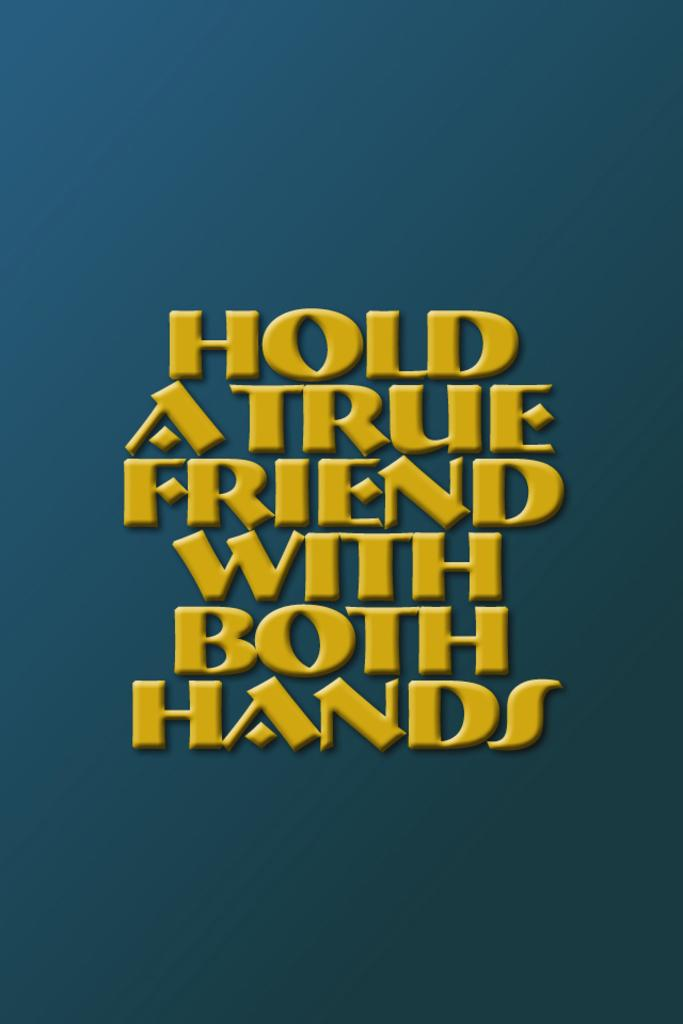<image>
Give a short and clear explanation of the subsequent image. a blue and yellow sign that read hold a true friend with both hands 